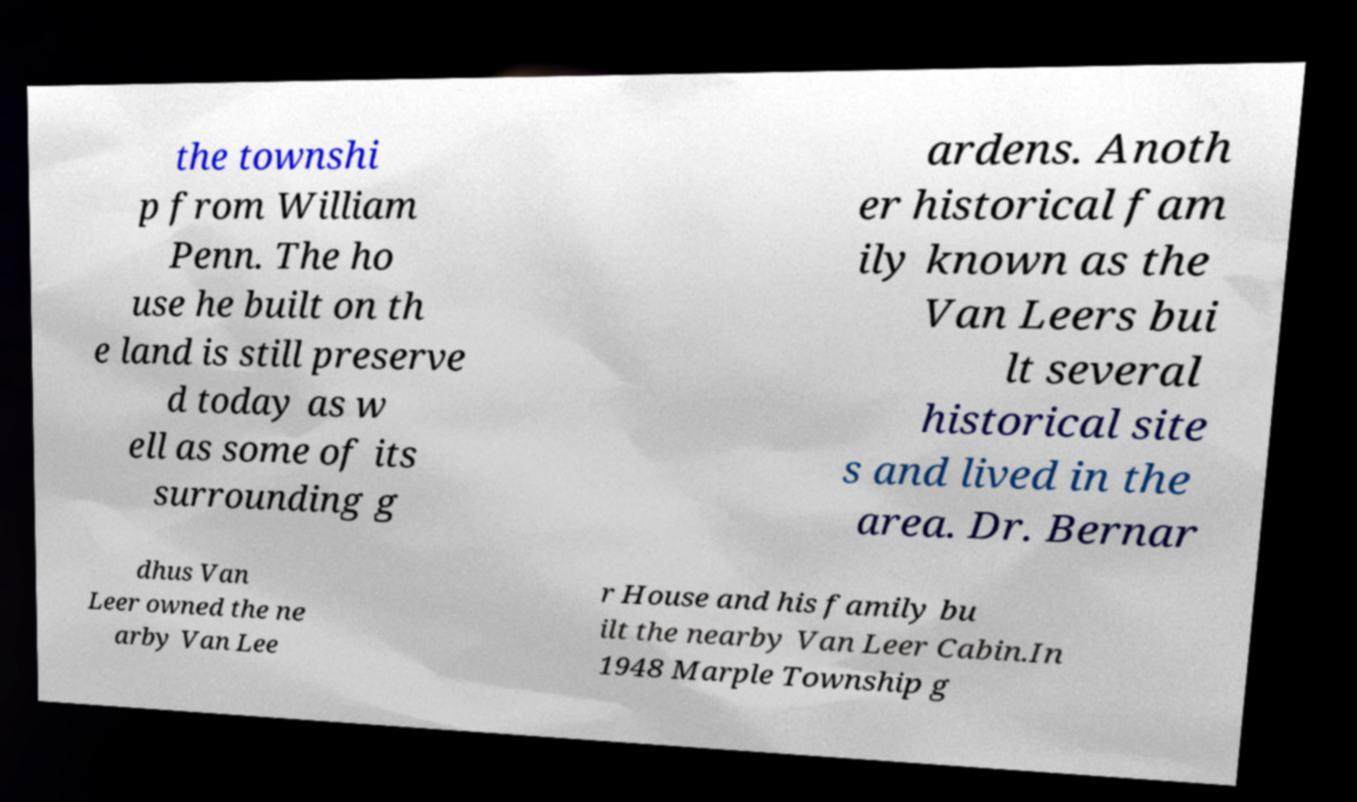I need the written content from this picture converted into text. Can you do that? the townshi p from William Penn. The ho use he built on th e land is still preserve d today as w ell as some of its surrounding g ardens. Anoth er historical fam ily known as the Van Leers bui lt several historical site s and lived in the area. Dr. Bernar dhus Van Leer owned the ne arby Van Lee r House and his family bu ilt the nearby Van Leer Cabin.In 1948 Marple Township g 